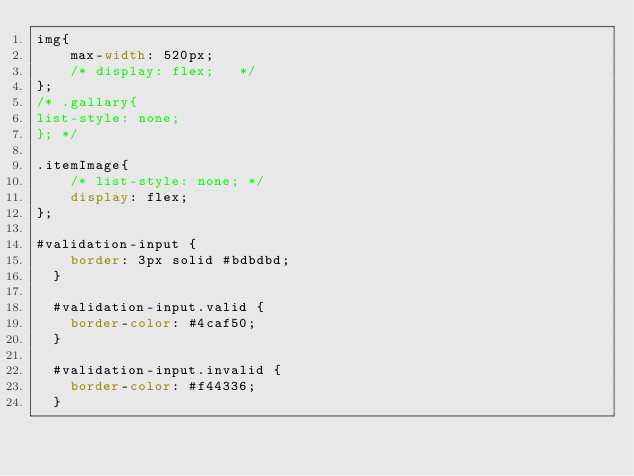Convert code to text. <code><loc_0><loc_0><loc_500><loc_500><_CSS_>img{
    max-width: 520px;
    /* display: flex;   */
};
/* .gallary{
list-style: none;
}; */

.itemImage{
    /* list-style: none; */
    display: flex;
};

#validation-input {
    border: 3px solid #bdbdbd;
  }
  
  #validation-input.valid {
    border-color: #4caf50;
  }
  
  #validation-input.invalid {
    border-color: #f44336;
  }</code> 